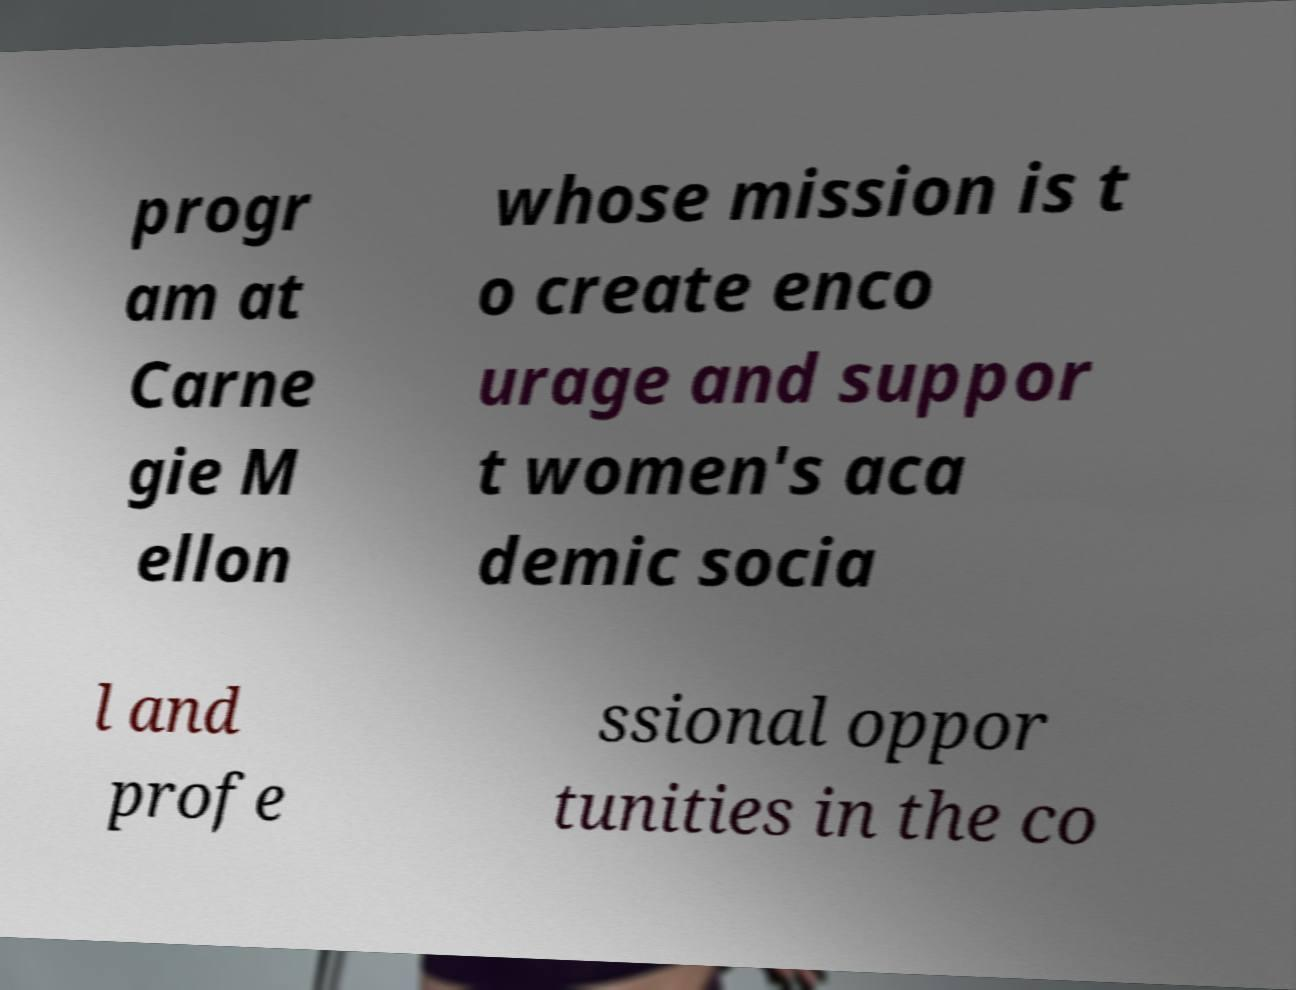I need the written content from this picture converted into text. Can you do that? progr am at Carne gie M ellon whose mission is t o create enco urage and suppor t women's aca demic socia l and profe ssional oppor tunities in the co 